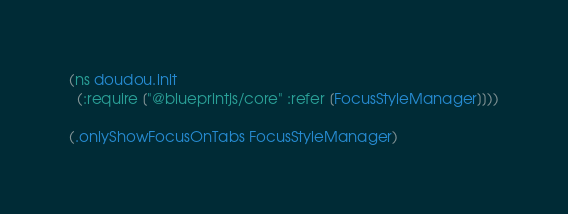Convert code to text. <code><loc_0><loc_0><loc_500><loc_500><_Clojure_>(ns doudou.init
  (:require ["@blueprintjs/core" :refer [FocusStyleManager]]))

(.onlyShowFocusOnTabs FocusStyleManager)


</code> 